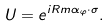<formula> <loc_0><loc_0><loc_500><loc_500>U = e ^ { i R m \alpha _ { \varphi } \cdot \sigma } .</formula> 